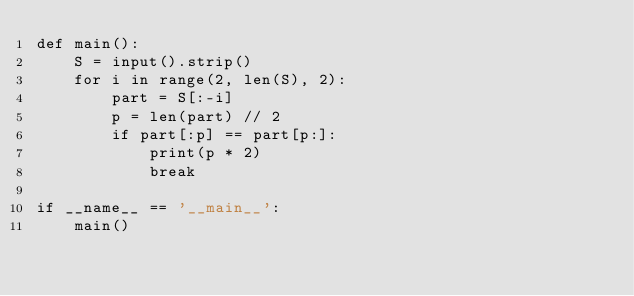Convert code to text. <code><loc_0><loc_0><loc_500><loc_500><_Python_>def main():
    S = input().strip()
    for i in range(2, len(S), 2):
        part = S[:-i]
        p = len(part) // 2
        if part[:p] == part[p:]:
            print(p * 2)
            break

if __name__ == '__main__':
    main()
</code> 